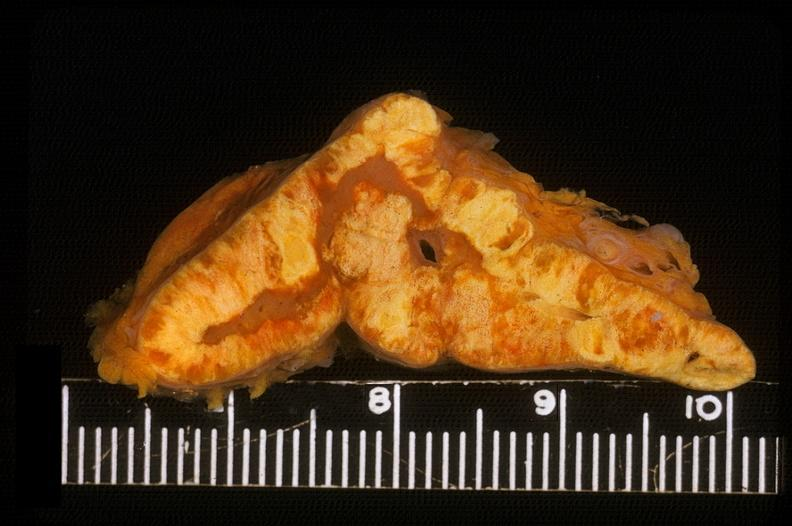s anomalous origin present?
Answer the question using a single word or phrase. No 